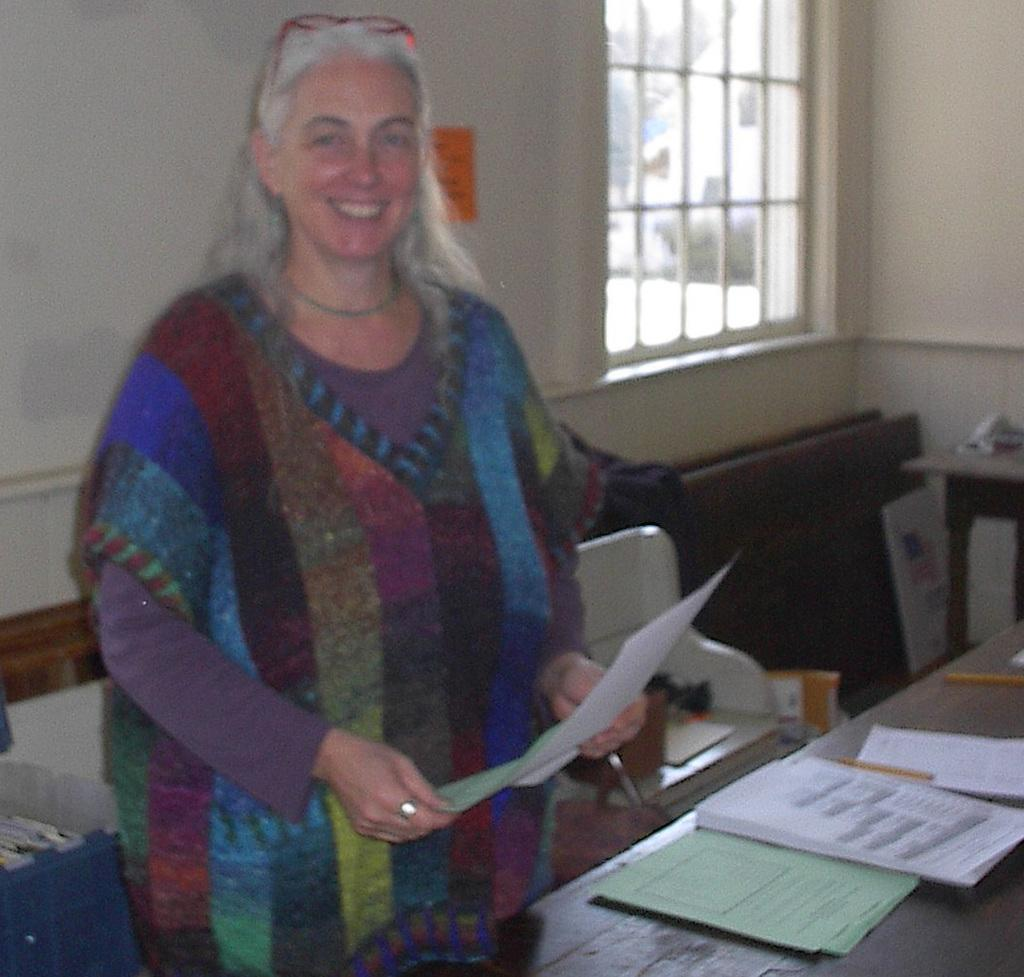What is the main subject in the image? There is a woman standing in the image. Where is the woman standing? The woman is standing on the floor. What can be seen on the table in the image? There are papers on the table. What is visible in the background of the image? There is a wall and a window in the background of the image. What type of toothpaste is the woman using in the image? There is no toothpaste present in the image; it features a woman standing with a table and papers in the background. 